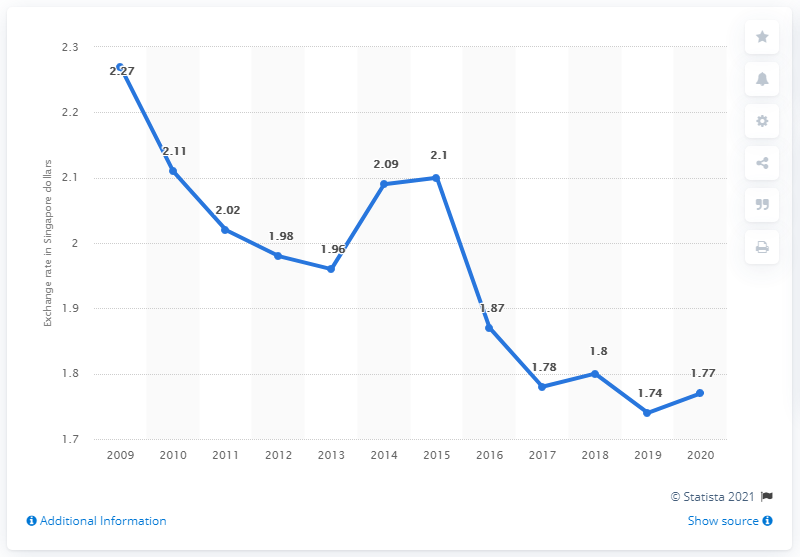Give some essential details in this illustration. In 2020, the average exchange rate from Singapore dollar to pound sterling was 1.77 Singapore dollars equivalent to 1 British pound. The average exchange rate from Singapore dollar to pound sterling in 2020 was 1.77 pounds per Singapore dollar. 